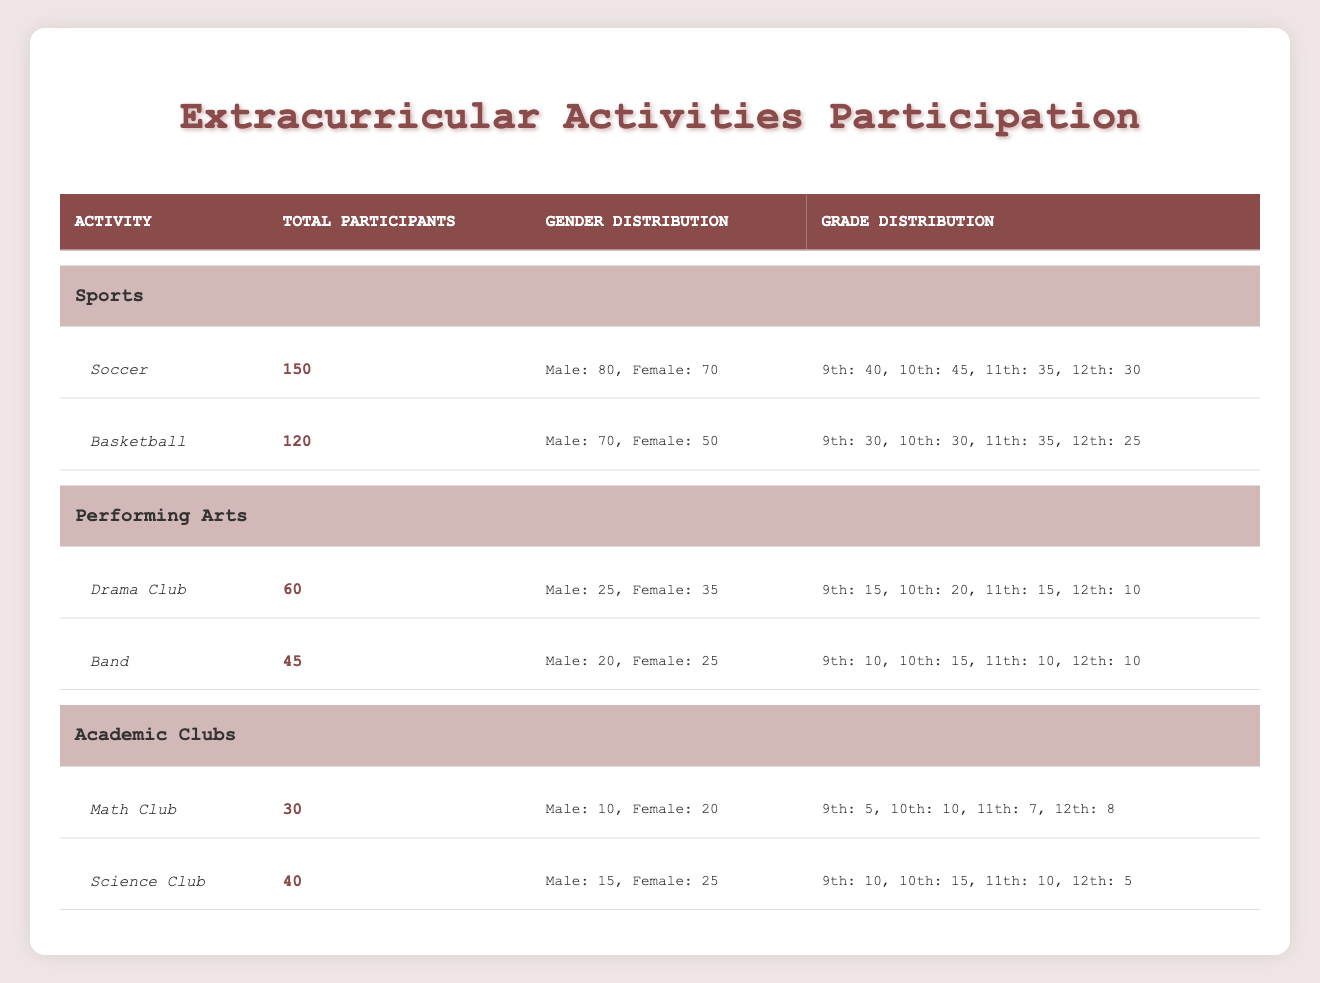What is the total number of participants in the Soccer activity? The total number of participants listed for Soccer is directly stated in the table under the "Total Participants" column. It shows that there are 150 participants.
Answer: 150 How many female participants are in the Basketball activity? The table specifies that there are 50 female participants in the Basketball activity, which is found under the "Gender Distribution" column for Basketball.
Answer: 50 Which activity has the highest total participants? By examining the total participants for each activity, Soccer has 150 participants, Basketball has 120, Drama Club has 60, Band has 45, Math Club has 30, and Science Club has 40. Soccer has the highest value at 150.
Answer: Soccer What is the total number of male participants across all activities? The total number of male participants can be calculated by adding the male participants from each activity: Soccer (80) + Basketball (70) + Drama Club (25) + Band (20) + Math Club (10) + Science Club (15) = 320.
Answer: 320 Is the number of female participants in the Drama Club greater than those in the Band? The Drama Club has 35 female participants and the Band has 25 female participants. Since 35 is greater than 25, the answer is yes.
Answer: Yes What is the average number of participants in Academic Clubs? In the Academic Clubs category, Math Club has 30 participants and Science Club has 40 participants. The average can be calculated as (30 + 40) / 2 = 35.
Answer: 35 Which grade has the most participants in the Soccer activity? The grade distribution for Soccer shows 9th grade has 40, 10th grade has 45, 11th grade has 35, and 12th grade has 30. The 10th grade with 45 participants is the highest.
Answer: 10th grade How many more males are in the Science Club than in the Math Club? The Science Club has 15 male participants while the Math Club has 10. To find the difference, subtract: 15 - 10 = 5.
Answer: 5 In total, how many participants are in the Performing Arts activities? The total participants in Performing Arts activities can be calculated by adding the Drama Club (60) and Band (45) participants: 60 + 45 = 105.
Answer: 105 